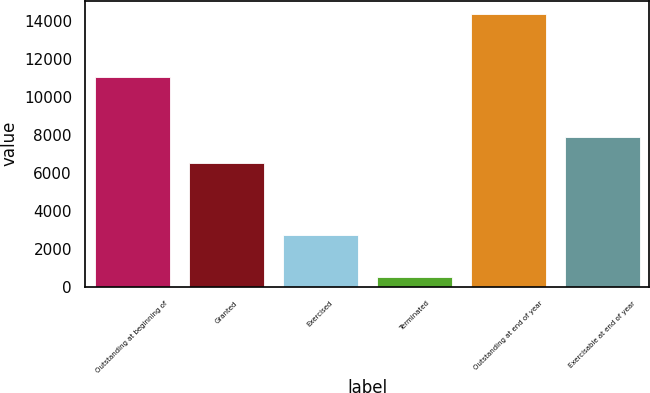<chart> <loc_0><loc_0><loc_500><loc_500><bar_chart><fcel>Outstanding at beginning of<fcel>Granted<fcel>Exercised<fcel>Terminated<fcel>Outstanding at end of year<fcel>Exercisable at end of year<nl><fcel>11049<fcel>6484<fcel>2707<fcel>503<fcel>14323<fcel>7866<nl></chart> 